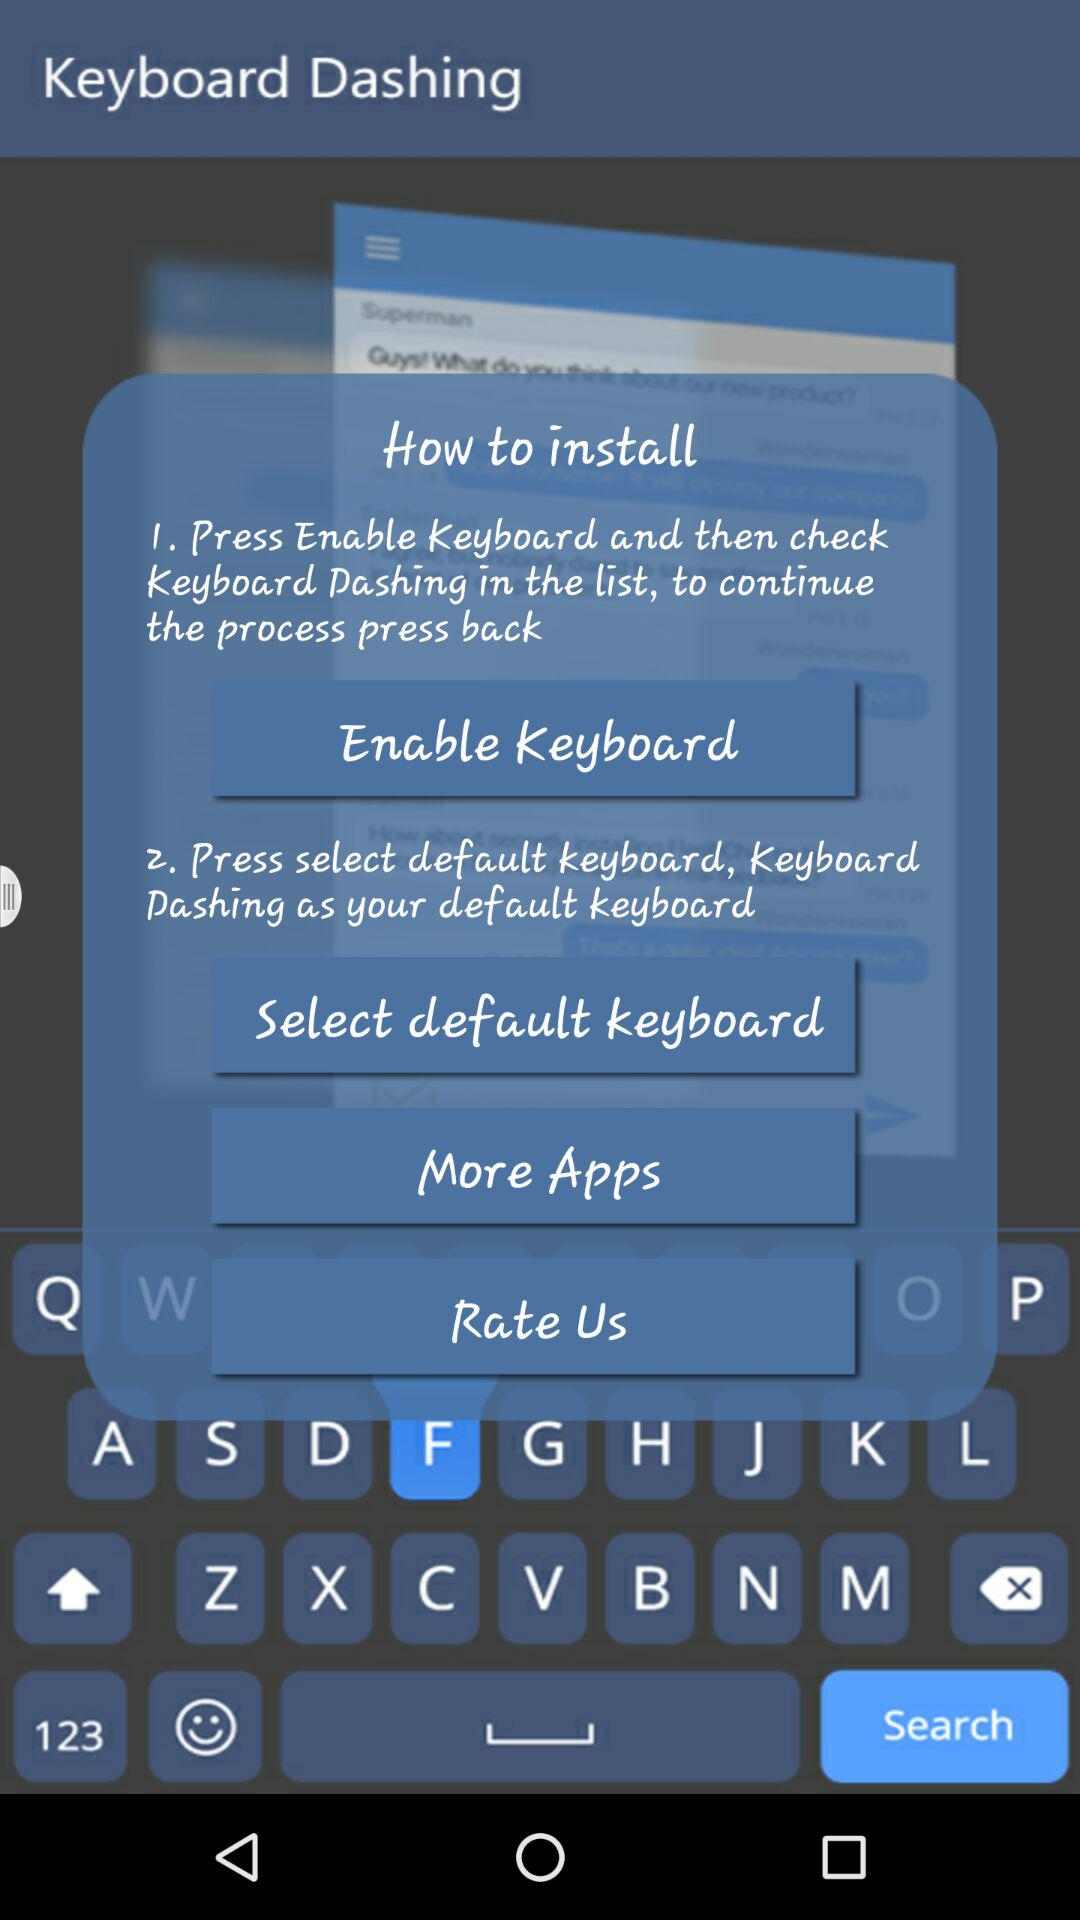How many steps are there to install Keyboard Dashing?
Answer the question using a single word or phrase. 2 